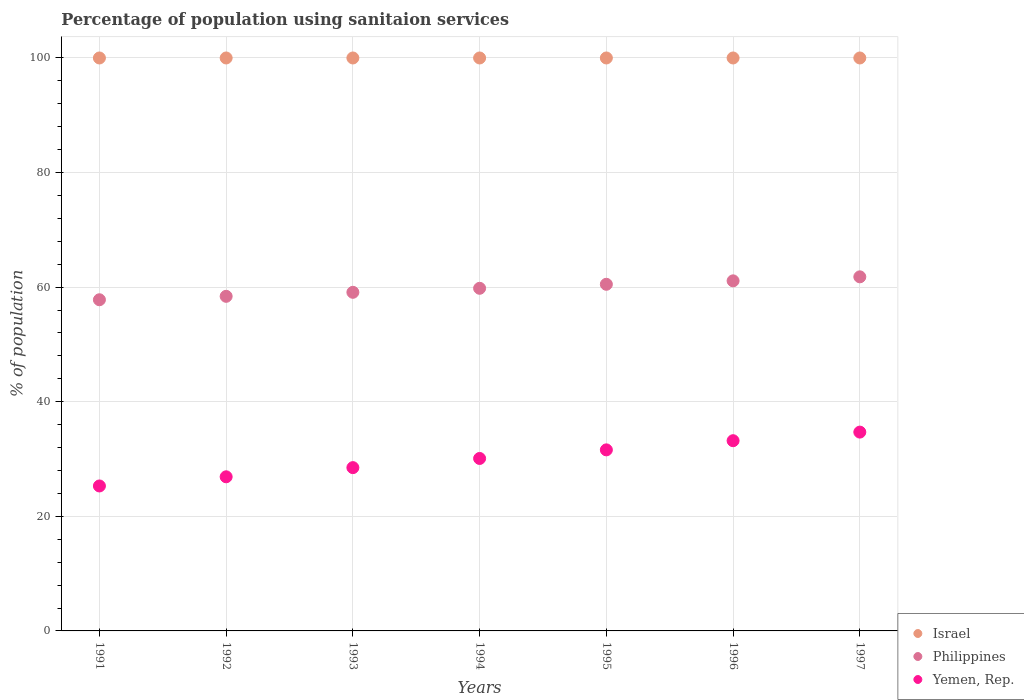How many different coloured dotlines are there?
Offer a terse response. 3. What is the percentage of population using sanitaion services in Philippines in 1993?
Ensure brevity in your answer.  59.1. Across all years, what is the maximum percentage of population using sanitaion services in Yemen, Rep.?
Ensure brevity in your answer.  34.7. Across all years, what is the minimum percentage of population using sanitaion services in Yemen, Rep.?
Provide a succinct answer. 25.3. In which year was the percentage of population using sanitaion services in Philippines maximum?
Your answer should be compact. 1997. In which year was the percentage of population using sanitaion services in Yemen, Rep. minimum?
Make the answer very short. 1991. What is the total percentage of population using sanitaion services in Israel in the graph?
Provide a short and direct response. 700. What is the difference between the percentage of population using sanitaion services in Philippines in 1994 and that in 1995?
Your answer should be very brief. -0.7. What is the difference between the percentage of population using sanitaion services in Israel in 1991 and the percentage of population using sanitaion services in Yemen, Rep. in 1994?
Offer a terse response. 69.9. What is the average percentage of population using sanitaion services in Philippines per year?
Your answer should be compact. 59.79. In the year 1991, what is the difference between the percentage of population using sanitaion services in Philippines and percentage of population using sanitaion services in Yemen, Rep.?
Your answer should be very brief. 32.5. In how many years, is the percentage of population using sanitaion services in Philippines greater than 76 %?
Offer a terse response. 0. What is the ratio of the percentage of population using sanitaion services in Philippines in 1991 to that in 1997?
Your answer should be compact. 0.94. What is the difference between the highest and the second highest percentage of population using sanitaion services in Philippines?
Keep it short and to the point. 0.7. In how many years, is the percentage of population using sanitaion services in Israel greater than the average percentage of population using sanitaion services in Israel taken over all years?
Offer a terse response. 0. Does the percentage of population using sanitaion services in Israel monotonically increase over the years?
Your answer should be very brief. No. Is the percentage of population using sanitaion services in Philippines strictly less than the percentage of population using sanitaion services in Israel over the years?
Provide a succinct answer. Yes. How many years are there in the graph?
Keep it short and to the point. 7. Does the graph contain any zero values?
Ensure brevity in your answer.  No. Does the graph contain grids?
Your response must be concise. Yes. Where does the legend appear in the graph?
Ensure brevity in your answer.  Bottom right. How many legend labels are there?
Give a very brief answer. 3. What is the title of the graph?
Offer a very short reply. Percentage of population using sanitaion services. What is the label or title of the X-axis?
Your response must be concise. Years. What is the label or title of the Y-axis?
Make the answer very short. % of population. What is the % of population in Philippines in 1991?
Offer a very short reply. 57.8. What is the % of population of Yemen, Rep. in 1991?
Your response must be concise. 25.3. What is the % of population in Philippines in 1992?
Keep it short and to the point. 58.4. What is the % of population of Yemen, Rep. in 1992?
Offer a very short reply. 26.9. What is the % of population in Philippines in 1993?
Provide a succinct answer. 59.1. What is the % of population of Yemen, Rep. in 1993?
Offer a very short reply. 28.5. What is the % of population in Philippines in 1994?
Ensure brevity in your answer.  59.8. What is the % of population in Yemen, Rep. in 1994?
Offer a very short reply. 30.1. What is the % of population in Philippines in 1995?
Keep it short and to the point. 60.5. What is the % of population of Yemen, Rep. in 1995?
Provide a short and direct response. 31.6. What is the % of population of Israel in 1996?
Offer a very short reply. 100. What is the % of population of Philippines in 1996?
Make the answer very short. 61.1. What is the % of population of Yemen, Rep. in 1996?
Keep it short and to the point. 33.2. What is the % of population in Israel in 1997?
Provide a short and direct response. 100. What is the % of population in Philippines in 1997?
Your response must be concise. 61.8. What is the % of population of Yemen, Rep. in 1997?
Provide a short and direct response. 34.7. Across all years, what is the maximum % of population in Philippines?
Your answer should be compact. 61.8. Across all years, what is the maximum % of population in Yemen, Rep.?
Give a very brief answer. 34.7. Across all years, what is the minimum % of population in Philippines?
Offer a very short reply. 57.8. Across all years, what is the minimum % of population of Yemen, Rep.?
Your answer should be compact. 25.3. What is the total % of population of Israel in the graph?
Make the answer very short. 700. What is the total % of population in Philippines in the graph?
Provide a succinct answer. 418.5. What is the total % of population of Yemen, Rep. in the graph?
Your answer should be very brief. 210.3. What is the difference between the % of population in Philippines in 1991 and that in 1992?
Offer a terse response. -0.6. What is the difference between the % of population of Israel in 1991 and that in 1994?
Your answer should be compact. 0. What is the difference between the % of population in Yemen, Rep. in 1991 and that in 1994?
Your answer should be compact. -4.8. What is the difference between the % of population in Yemen, Rep. in 1991 and that in 1995?
Provide a succinct answer. -6.3. What is the difference between the % of population of Israel in 1991 and that in 1996?
Make the answer very short. 0. What is the difference between the % of population of Yemen, Rep. in 1991 and that in 1996?
Provide a short and direct response. -7.9. What is the difference between the % of population of Israel in 1991 and that in 1997?
Give a very brief answer. 0. What is the difference between the % of population in Philippines in 1991 and that in 1997?
Your response must be concise. -4. What is the difference between the % of population of Yemen, Rep. in 1991 and that in 1997?
Offer a very short reply. -9.4. What is the difference between the % of population of Philippines in 1992 and that in 1993?
Make the answer very short. -0.7. What is the difference between the % of population in Yemen, Rep. in 1992 and that in 1994?
Offer a very short reply. -3.2. What is the difference between the % of population of Israel in 1992 and that in 1995?
Offer a very short reply. 0. What is the difference between the % of population of Philippines in 1992 and that in 1995?
Ensure brevity in your answer.  -2.1. What is the difference between the % of population in Yemen, Rep. in 1992 and that in 1995?
Offer a very short reply. -4.7. What is the difference between the % of population of Israel in 1992 and that in 1996?
Provide a succinct answer. 0. What is the difference between the % of population in Philippines in 1992 and that in 1996?
Provide a succinct answer. -2.7. What is the difference between the % of population of Yemen, Rep. in 1992 and that in 1996?
Your answer should be very brief. -6.3. What is the difference between the % of population in Yemen, Rep. in 1993 and that in 1994?
Offer a very short reply. -1.6. What is the difference between the % of population of Israel in 1993 and that in 1995?
Offer a very short reply. 0. What is the difference between the % of population in Israel in 1993 and that in 1996?
Your answer should be very brief. 0. What is the difference between the % of population in Philippines in 1993 and that in 1996?
Give a very brief answer. -2. What is the difference between the % of population of Israel in 1994 and that in 1995?
Ensure brevity in your answer.  0. What is the difference between the % of population in Philippines in 1994 and that in 1996?
Your response must be concise. -1.3. What is the difference between the % of population in Yemen, Rep. in 1994 and that in 1996?
Your answer should be compact. -3.1. What is the difference between the % of population of Philippines in 1994 and that in 1997?
Keep it short and to the point. -2. What is the difference between the % of population in Yemen, Rep. in 1995 and that in 1996?
Offer a very short reply. -1.6. What is the difference between the % of population in Philippines in 1995 and that in 1997?
Offer a very short reply. -1.3. What is the difference between the % of population of Israel in 1996 and that in 1997?
Provide a short and direct response. 0. What is the difference between the % of population in Yemen, Rep. in 1996 and that in 1997?
Ensure brevity in your answer.  -1.5. What is the difference between the % of population in Israel in 1991 and the % of population in Philippines in 1992?
Your answer should be compact. 41.6. What is the difference between the % of population in Israel in 1991 and the % of population in Yemen, Rep. in 1992?
Give a very brief answer. 73.1. What is the difference between the % of population in Philippines in 1991 and the % of population in Yemen, Rep. in 1992?
Keep it short and to the point. 30.9. What is the difference between the % of population in Israel in 1991 and the % of population in Philippines in 1993?
Give a very brief answer. 40.9. What is the difference between the % of population in Israel in 1991 and the % of population in Yemen, Rep. in 1993?
Give a very brief answer. 71.5. What is the difference between the % of population of Philippines in 1991 and the % of population of Yemen, Rep. in 1993?
Provide a short and direct response. 29.3. What is the difference between the % of population in Israel in 1991 and the % of population in Philippines in 1994?
Your response must be concise. 40.2. What is the difference between the % of population of Israel in 1991 and the % of population of Yemen, Rep. in 1994?
Provide a short and direct response. 69.9. What is the difference between the % of population of Philippines in 1991 and the % of population of Yemen, Rep. in 1994?
Give a very brief answer. 27.7. What is the difference between the % of population of Israel in 1991 and the % of population of Philippines in 1995?
Offer a terse response. 39.5. What is the difference between the % of population of Israel in 1991 and the % of population of Yemen, Rep. in 1995?
Offer a terse response. 68.4. What is the difference between the % of population of Philippines in 1991 and the % of population of Yemen, Rep. in 1995?
Provide a succinct answer. 26.2. What is the difference between the % of population in Israel in 1991 and the % of population in Philippines in 1996?
Make the answer very short. 38.9. What is the difference between the % of population in Israel in 1991 and the % of population in Yemen, Rep. in 1996?
Provide a short and direct response. 66.8. What is the difference between the % of population of Philippines in 1991 and the % of population of Yemen, Rep. in 1996?
Your response must be concise. 24.6. What is the difference between the % of population in Israel in 1991 and the % of population in Philippines in 1997?
Provide a succinct answer. 38.2. What is the difference between the % of population of Israel in 1991 and the % of population of Yemen, Rep. in 1997?
Give a very brief answer. 65.3. What is the difference between the % of population in Philippines in 1991 and the % of population in Yemen, Rep. in 1997?
Your answer should be compact. 23.1. What is the difference between the % of population in Israel in 1992 and the % of population in Philippines in 1993?
Offer a terse response. 40.9. What is the difference between the % of population of Israel in 1992 and the % of population of Yemen, Rep. in 1993?
Provide a succinct answer. 71.5. What is the difference between the % of population of Philippines in 1992 and the % of population of Yemen, Rep. in 1993?
Offer a very short reply. 29.9. What is the difference between the % of population in Israel in 1992 and the % of population in Philippines in 1994?
Provide a short and direct response. 40.2. What is the difference between the % of population in Israel in 1992 and the % of population in Yemen, Rep. in 1994?
Ensure brevity in your answer.  69.9. What is the difference between the % of population of Philippines in 1992 and the % of population of Yemen, Rep. in 1994?
Your response must be concise. 28.3. What is the difference between the % of population of Israel in 1992 and the % of population of Philippines in 1995?
Your answer should be very brief. 39.5. What is the difference between the % of population of Israel in 1992 and the % of population of Yemen, Rep. in 1995?
Keep it short and to the point. 68.4. What is the difference between the % of population of Philippines in 1992 and the % of population of Yemen, Rep. in 1995?
Give a very brief answer. 26.8. What is the difference between the % of population in Israel in 1992 and the % of population in Philippines in 1996?
Your answer should be very brief. 38.9. What is the difference between the % of population in Israel in 1992 and the % of population in Yemen, Rep. in 1996?
Your answer should be compact. 66.8. What is the difference between the % of population in Philippines in 1992 and the % of population in Yemen, Rep. in 1996?
Keep it short and to the point. 25.2. What is the difference between the % of population in Israel in 1992 and the % of population in Philippines in 1997?
Your answer should be very brief. 38.2. What is the difference between the % of population in Israel in 1992 and the % of population in Yemen, Rep. in 1997?
Make the answer very short. 65.3. What is the difference between the % of population in Philippines in 1992 and the % of population in Yemen, Rep. in 1997?
Offer a very short reply. 23.7. What is the difference between the % of population of Israel in 1993 and the % of population of Philippines in 1994?
Keep it short and to the point. 40.2. What is the difference between the % of population in Israel in 1993 and the % of population in Yemen, Rep. in 1994?
Your answer should be compact. 69.9. What is the difference between the % of population in Philippines in 1993 and the % of population in Yemen, Rep. in 1994?
Your response must be concise. 29. What is the difference between the % of population of Israel in 1993 and the % of population of Philippines in 1995?
Ensure brevity in your answer.  39.5. What is the difference between the % of population of Israel in 1993 and the % of population of Yemen, Rep. in 1995?
Your answer should be compact. 68.4. What is the difference between the % of population in Israel in 1993 and the % of population in Philippines in 1996?
Provide a short and direct response. 38.9. What is the difference between the % of population of Israel in 1993 and the % of population of Yemen, Rep. in 1996?
Give a very brief answer. 66.8. What is the difference between the % of population of Philippines in 1993 and the % of population of Yemen, Rep. in 1996?
Your response must be concise. 25.9. What is the difference between the % of population of Israel in 1993 and the % of population of Philippines in 1997?
Offer a very short reply. 38.2. What is the difference between the % of population in Israel in 1993 and the % of population in Yemen, Rep. in 1997?
Ensure brevity in your answer.  65.3. What is the difference between the % of population in Philippines in 1993 and the % of population in Yemen, Rep. in 1997?
Provide a succinct answer. 24.4. What is the difference between the % of population of Israel in 1994 and the % of population of Philippines in 1995?
Make the answer very short. 39.5. What is the difference between the % of population of Israel in 1994 and the % of population of Yemen, Rep. in 1995?
Give a very brief answer. 68.4. What is the difference between the % of population of Philippines in 1994 and the % of population of Yemen, Rep. in 1995?
Provide a succinct answer. 28.2. What is the difference between the % of population of Israel in 1994 and the % of population of Philippines in 1996?
Ensure brevity in your answer.  38.9. What is the difference between the % of population of Israel in 1994 and the % of population of Yemen, Rep. in 1996?
Keep it short and to the point. 66.8. What is the difference between the % of population of Philippines in 1994 and the % of population of Yemen, Rep. in 1996?
Ensure brevity in your answer.  26.6. What is the difference between the % of population in Israel in 1994 and the % of population in Philippines in 1997?
Provide a succinct answer. 38.2. What is the difference between the % of population of Israel in 1994 and the % of population of Yemen, Rep. in 1997?
Give a very brief answer. 65.3. What is the difference between the % of population of Philippines in 1994 and the % of population of Yemen, Rep. in 1997?
Your answer should be very brief. 25.1. What is the difference between the % of population of Israel in 1995 and the % of population of Philippines in 1996?
Provide a short and direct response. 38.9. What is the difference between the % of population of Israel in 1995 and the % of population of Yemen, Rep. in 1996?
Provide a short and direct response. 66.8. What is the difference between the % of population in Philippines in 1995 and the % of population in Yemen, Rep. in 1996?
Keep it short and to the point. 27.3. What is the difference between the % of population of Israel in 1995 and the % of population of Philippines in 1997?
Make the answer very short. 38.2. What is the difference between the % of population in Israel in 1995 and the % of population in Yemen, Rep. in 1997?
Offer a terse response. 65.3. What is the difference between the % of population in Philippines in 1995 and the % of population in Yemen, Rep. in 1997?
Give a very brief answer. 25.8. What is the difference between the % of population of Israel in 1996 and the % of population of Philippines in 1997?
Ensure brevity in your answer.  38.2. What is the difference between the % of population in Israel in 1996 and the % of population in Yemen, Rep. in 1997?
Ensure brevity in your answer.  65.3. What is the difference between the % of population of Philippines in 1996 and the % of population of Yemen, Rep. in 1997?
Ensure brevity in your answer.  26.4. What is the average % of population of Israel per year?
Ensure brevity in your answer.  100. What is the average % of population in Philippines per year?
Keep it short and to the point. 59.79. What is the average % of population in Yemen, Rep. per year?
Offer a very short reply. 30.04. In the year 1991, what is the difference between the % of population of Israel and % of population of Philippines?
Ensure brevity in your answer.  42.2. In the year 1991, what is the difference between the % of population in Israel and % of population in Yemen, Rep.?
Make the answer very short. 74.7. In the year 1991, what is the difference between the % of population in Philippines and % of population in Yemen, Rep.?
Offer a very short reply. 32.5. In the year 1992, what is the difference between the % of population of Israel and % of population of Philippines?
Make the answer very short. 41.6. In the year 1992, what is the difference between the % of population in Israel and % of population in Yemen, Rep.?
Ensure brevity in your answer.  73.1. In the year 1992, what is the difference between the % of population in Philippines and % of population in Yemen, Rep.?
Offer a terse response. 31.5. In the year 1993, what is the difference between the % of population of Israel and % of population of Philippines?
Ensure brevity in your answer.  40.9. In the year 1993, what is the difference between the % of population of Israel and % of population of Yemen, Rep.?
Your response must be concise. 71.5. In the year 1993, what is the difference between the % of population of Philippines and % of population of Yemen, Rep.?
Your answer should be compact. 30.6. In the year 1994, what is the difference between the % of population of Israel and % of population of Philippines?
Your answer should be compact. 40.2. In the year 1994, what is the difference between the % of population in Israel and % of population in Yemen, Rep.?
Your response must be concise. 69.9. In the year 1994, what is the difference between the % of population in Philippines and % of population in Yemen, Rep.?
Offer a terse response. 29.7. In the year 1995, what is the difference between the % of population in Israel and % of population in Philippines?
Offer a terse response. 39.5. In the year 1995, what is the difference between the % of population of Israel and % of population of Yemen, Rep.?
Make the answer very short. 68.4. In the year 1995, what is the difference between the % of population in Philippines and % of population in Yemen, Rep.?
Provide a succinct answer. 28.9. In the year 1996, what is the difference between the % of population in Israel and % of population in Philippines?
Provide a succinct answer. 38.9. In the year 1996, what is the difference between the % of population in Israel and % of population in Yemen, Rep.?
Provide a succinct answer. 66.8. In the year 1996, what is the difference between the % of population in Philippines and % of population in Yemen, Rep.?
Provide a succinct answer. 27.9. In the year 1997, what is the difference between the % of population in Israel and % of population in Philippines?
Make the answer very short. 38.2. In the year 1997, what is the difference between the % of population of Israel and % of population of Yemen, Rep.?
Your answer should be very brief. 65.3. In the year 1997, what is the difference between the % of population in Philippines and % of population in Yemen, Rep.?
Your answer should be compact. 27.1. What is the ratio of the % of population in Philippines in 1991 to that in 1992?
Provide a short and direct response. 0.99. What is the ratio of the % of population of Yemen, Rep. in 1991 to that in 1992?
Provide a succinct answer. 0.94. What is the ratio of the % of population in Philippines in 1991 to that in 1993?
Give a very brief answer. 0.98. What is the ratio of the % of population of Yemen, Rep. in 1991 to that in 1993?
Give a very brief answer. 0.89. What is the ratio of the % of population in Israel in 1991 to that in 1994?
Make the answer very short. 1. What is the ratio of the % of population in Philippines in 1991 to that in 1994?
Make the answer very short. 0.97. What is the ratio of the % of population in Yemen, Rep. in 1991 to that in 1994?
Ensure brevity in your answer.  0.84. What is the ratio of the % of population of Israel in 1991 to that in 1995?
Your response must be concise. 1. What is the ratio of the % of population in Philippines in 1991 to that in 1995?
Give a very brief answer. 0.96. What is the ratio of the % of population of Yemen, Rep. in 1991 to that in 1995?
Provide a short and direct response. 0.8. What is the ratio of the % of population of Philippines in 1991 to that in 1996?
Your response must be concise. 0.95. What is the ratio of the % of population in Yemen, Rep. in 1991 to that in 1996?
Your answer should be very brief. 0.76. What is the ratio of the % of population in Israel in 1991 to that in 1997?
Your answer should be very brief. 1. What is the ratio of the % of population in Philippines in 1991 to that in 1997?
Offer a terse response. 0.94. What is the ratio of the % of population of Yemen, Rep. in 1991 to that in 1997?
Offer a very short reply. 0.73. What is the ratio of the % of population of Israel in 1992 to that in 1993?
Your answer should be compact. 1. What is the ratio of the % of population in Yemen, Rep. in 1992 to that in 1993?
Offer a terse response. 0.94. What is the ratio of the % of population in Philippines in 1992 to that in 1994?
Your response must be concise. 0.98. What is the ratio of the % of population of Yemen, Rep. in 1992 to that in 1994?
Provide a short and direct response. 0.89. What is the ratio of the % of population of Israel in 1992 to that in 1995?
Your answer should be very brief. 1. What is the ratio of the % of population of Philippines in 1992 to that in 1995?
Your answer should be compact. 0.97. What is the ratio of the % of population in Yemen, Rep. in 1992 to that in 1995?
Your response must be concise. 0.85. What is the ratio of the % of population of Israel in 1992 to that in 1996?
Your answer should be compact. 1. What is the ratio of the % of population in Philippines in 1992 to that in 1996?
Provide a short and direct response. 0.96. What is the ratio of the % of population of Yemen, Rep. in 1992 to that in 1996?
Your response must be concise. 0.81. What is the ratio of the % of population in Israel in 1992 to that in 1997?
Offer a terse response. 1. What is the ratio of the % of population in Philippines in 1992 to that in 1997?
Provide a short and direct response. 0.94. What is the ratio of the % of population of Yemen, Rep. in 1992 to that in 1997?
Provide a short and direct response. 0.78. What is the ratio of the % of population of Philippines in 1993 to that in 1994?
Your answer should be compact. 0.99. What is the ratio of the % of population of Yemen, Rep. in 1993 to that in 1994?
Provide a short and direct response. 0.95. What is the ratio of the % of population in Israel in 1993 to that in 1995?
Your answer should be compact. 1. What is the ratio of the % of population in Philippines in 1993 to that in 1995?
Your answer should be very brief. 0.98. What is the ratio of the % of population of Yemen, Rep. in 1993 to that in 1995?
Provide a short and direct response. 0.9. What is the ratio of the % of population of Philippines in 1993 to that in 1996?
Make the answer very short. 0.97. What is the ratio of the % of population in Yemen, Rep. in 1993 to that in 1996?
Provide a succinct answer. 0.86. What is the ratio of the % of population of Israel in 1993 to that in 1997?
Ensure brevity in your answer.  1. What is the ratio of the % of population of Philippines in 1993 to that in 1997?
Provide a succinct answer. 0.96. What is the ratio of the % of population in Yemen, Rep. in 1993 to that in 1997?
Offer a terse response. 0.82. What is the ratio of the % of population in Philippines in 1994 to that in 1995?
Provide a succinct answer. 0.99. What is the ratio of the % of population in Yemen, Rep. in 1994 to that in 1995?
Make the answer very short. 0.95. What is the ratio of the % of population in Philippines in 1994 to that in 1996?
Offer a very short reply. 0.98. What is the ratio of the % of population of Yemen, Rep. in 1994 to that in 1996?
Ensure brevity in your answer.  0.91. What is the ratio of the % of population of Philippines in 1994 to that in 1997?
Give a very brief answer. 0.97. What is the ratio of the % of population of Yemen, Rep. in 1994 to that in 1997?
Provide a succinct answer. 0.87. What is the ratio of the % of population in Philippines in 1995 to that in 1996?
Provide a succinct answer. 0.99. What is the ratio of the % of population in Yemen, Rep. in 1995 to that in 1996?
Ensure brevity in your answer.  0.95. What is the ratio of the % of population in Yemen, Rep. in 1995 to that in 1997?
Ensure brevity in your answer.  0.91. What is the ratio of the % of population in Philippines in 1996 to that in 1997?
Make the answer very short. 0.99. What is the ratio of the % of population in Yemen, Rep. in 1996 to that in 1997?
Ensure brevity in your answer.  0.96. What is the difference between the highest and the second highest % of population in Israel?
Ensure brevity in your answer.  0. What is the difference between the highest and the second highest % of population in Yemen, Rep.?
Your response must be concise. 1.5. What is the difference between the highest and the lowest % of population of Israel?
Give a very brief answer. 0. What is the difference between the highest and the lowest % of population of Yemen, Rep.?
Give a very brief answer. 9.4. 